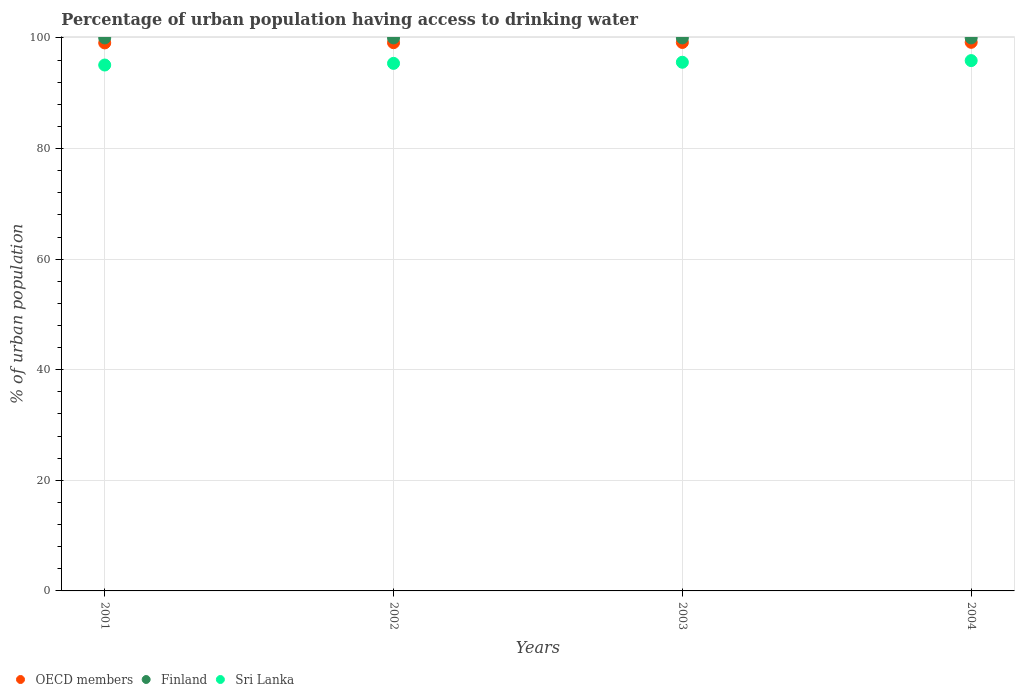How many different coloured dotlines are there?
Offer a very short reply. 3. Is the number of dotlines equal to the number of legend labels?
Your answer should be very brief. Yes. What is the percentage of urban population having access to drinking water in Sri Lanka in 2002?
Offer a very short reply. 95.4. Across all years, what is the maximum percentage of urban population having access to drinking water in OECD members?
Ensure brevity in your answer.  99.21. Across all years, what is the minimum percentage of urban population having access to drinking water in Finland?
Keep it short and to the point. 100. In which year was the percentage of urban population having access to drinking water in OECD members maximum?
Your answer should be compact. 2004. In which year was the percentage of urban population having access to drinking water in Finland minimum?
Your response must be concise. 2001. What is the total percentage of urban population having access to drinking water in Sri Lanka in the graph?
Provide a succinct answer. 382. What is the difference between the percentage of urban population having access to drinking water in Sri Lanka in 2002 and that in 2003?
Keep it short and to the point. -0.2. What is the difference between the percentage of urban population having access to drinking water in OECD members in 2004 and the percentage of urban population having access to drinking water in Finland in 2003?
Your answer should be compact. -0.79. In the year 2001, what is the difference between the percentage of urban population having access to drinking water in Sri Lanka and percentage of urban population having access to drinking water in Finland?
Ensure brevity in your answer.  -4.9. In how many years, is the percentage of urban population having access to drinking water in Finland greater than 12 %?
Your response must be concise. 4. Is the percentage of urban population having access to drinking water in OECD members in 2002 less than that in 2003?
Your answer should be very brief. Yes. What is the difference between the highest and the second highest percentage of urban population having access to drinking water in OECD members?
Offer a terse response. 0.03. What is the difference between the highest and the lowest percentage of urban population having access to drinking water in Sri Lanka?
Your answer should be compact. 0.8. Is the sum of the percentage of urban population having access to drinking water in Sri Lanka in 2002 and 2003 greater than the maximum percentage of urban population having access to drinking water in OECD members across all years?
Keep it short and to the point. Yes. Is it the case that in every year, the sum of the percentage of urban population having access to drinking water in OECD members and percentage of urban population having access to drinking water in Finland  is greater than the percentage of urban population having access to drinking water in Sri Lanka?
Ensure brevity in your answer.  Yes. Is the percentage of urban population having access to drinking water in OECD members strictly less than the percentage of urban population having access to drinking water in Finland over the years?
Provide a succinct answer. Yes. What is the difference between two consecutive major ticks on the Y-axis?
Offer a terse response. 20. Does the graph contain grids?
Ensure brevity in your answer.  Yes. How many legend labels are there?
Your response must be concise. 3. What is the title of the graph?
Offer a very short reply. Percentage of urban population having access to drinking water. What is the label or title of the X-axis?
Give a very brief answer. Years. What is the label or title of the Y-axis?
Give a very brief answer. % of urban population. What is the % of urban population in OECD members in 2001?
Your response must be concise. 99.1. What is the % of urban population in Finland in 2001?
Offer a very short reply. 100. What is the % of urban population of Sri Lanka in 2001?
Provide a short and direct response. 95.1. What is the % of urban population of OECD members in 2002?
Offer a very short reply. 99.14. What is the % of urban population in Finland in 2002?
Give a very brief answer. 100. What is the % of urban population of Sri Lanka in 2002?
Provide a short and direct response. 95.4. What is the % of urban population in OECD members in 2003?
Your answer should be very brief. 99.18. What is the % of urban population of Sri Lanka in 2003?
Keep it short and to the point. 95.6. What is the % of urban population of OECD members in 2004?
Make the answer very short. 99.21. What is the % of urban population in Finland in 2004?
Give a very brief answer. 100. What is the % of urban population of Sri Lanka in 2004?
Keep it short and to the point. 95.9. Across all years, what is the maximum % of urban population in OECD members?
Make the answer very short. 99.21. Across all years, what is the maximum % of urban population in Sri Lanka?
Provide a succinct answer. 95.9. Across all years, what is the minimum % of urban population in OECD members?
Provide a short and direct response. 99.1. Across all years, what is the minimum % of urban population of Sri Lanka?
Your answer should be compact. 95.1. What is the total % of urban population of OECD members in the graph?
Give a very brief answer. 396.63. What is the total % of urban population in Finland in the graph?
Provide a short and direct response. 400. What is the total % of urban population of Sri Lanka in the graph?
Give a very brief answer. 382. What is the difference between the % of urban population in OECD members in 2001 and that in 2002?
Ensure brevity in your answer.  -0.04. What is the difference between the % of urban population in Finland in 2001 and that in 2002?
Keep it short and to the point. 0. What is the difference between the % of urban population in OECD members in 2001 and that in 2003?
Offer a very short reply. -0.08. What is the difference between the % of urban population in Finland in 2001 and that in 2003?
Provide a short and direct response. 0. What is the difference between the % of urban population of Sri Lanka in 2001 and that in 2003?
Your answer should be compact. -0.5. What is the difference between the % of urban population of OECD members in 2001 and that in 2004?
Ensure brevity in your answer.  -0.11. What is the difference between the % of urban population in Finland in 2001 and that in 2004?
Your response must be concise. 0. What is the difference between the % of urban population in Sri Lanka in 2001 and that in 2004?
Make the answer very short. -0.8. What is the difference between the % of urban population in OECD members in 2002 and that in 2003?
Keep it short and to the point. -0.04. What is the difference between the % of urban population of Finland in 2002 and that in 2003?
Your response must be concise. 0. What is the difference between the % of urban population in OECD members in 2002 and that in 2004?
Keep it short and to the point. -0.06. What is the difference between the % of urban population in OECD members in 2003 and that in 2004?
Keep it short and to the point. -0.03. What is the difference between the % of urban population of OECD members in 2001 and the % of urban population of Finland in 2002?
Offer a very short reply. -0.9. What is the difference between the % of urban population in OECD members in 2001 and the % of urban population in Sri Lanka in 2002?
Keep it short and to the point. 3.7. What is the difference between the % of urban population of OECD members in 2001 and the % of urban population of Finland in 2003?
Provide a short and direct response. -0.9. What is the difference between the % of urban population in OECD members in 2001 and the % of urban population in Sri Lanka in 2003?
Your answer should be compact. 3.5. What is the difference between the % of urban population in Finland in 2001 and the % of urban population in Sri Lanka in 2003?
Make the answer very short. 4.4. What is the difference between the % of urban population in OECD members in 2001 and the % of urban population in Finland in 2004?
Your answer should be compact. -0.9. What is the difference between the % of urban population in OECD members in 2001 and the % of urban population in Sri Lanka in 2004?
Offer a very short reply. 3.2. What is the difference between the % of urban population of Finland in 2001 and the % of urban population of Sri Lanka in 2004?
Give a very brief answer. 4.1. What is the difference between the % of urban population of OECD members in 2002 and the % of urban population of Finland in 2003?
Ensure brevity in your answer.  -0.86. What is the difference between the % of urban population of OECD members in 2002 and the % of urban population of Sri Lanka in 2003?
Make the answer very short. 3.54. What is the difference between the % of urban population in OECD members in 2002 and the % of urban population in Finland in 2004?
Offer a very short reply. -0.86. What is the difference between the % of urban population of OECD members in 2002 and the % of urban population of Sri Lanka in 2004?
Ensure brevity in your answer.  3.24. What is the difference between the % of urban population of OECD members in 2003 and the % of urban population of Finland in 2004?
Provide a succinct answer. -0.82. What is the difference between the % of urban population in OECD members in 2003 and the % of urban population in Sri Lanka in 2004?
Your answer should be compact. 3.28. What is the average % of urban population in OECD members per year?
Your response must be concise. 99.16. What is the average % of urban population of Finland per year?
Provide a short and direct response. 100. What is the average % of urban population of Sri Lanka per year?
Keep it short and to the point. 95.5. In the year 2001, what is the difference between the % of urban population of OECD members and % of urban population of Finland?
Offer a very short reply. -0.9. In the year 2001, what is the difference between the % of urban population in OECD members and % of urban population in Sri Lanka?
Offer a terse response. 4. In the year 2002, what is the difference between the % of urban population of OECD members and % of urban population of Finland?
Offer a terse response. -0.86. In the year 2002, what is the difference between the % of urban population in OECD members and % of urban population in Sri Lanka?
Keep it short and to the point. 3.74. In the year 2003, what is the difference between the % of urban population of OECD members and % of urban population of Finland?
Ensure brevity in your answer.  -0.82. In the year 2003, what is the difference between the % of urban population of OECD members and % of urban population of Sri Lanka?
Make the answer very short. 3.58. In the year 2003, what is the difference between the % of urban population in Finland and % of urban population in Sri Lanka?
Offer a terse response. 4.4. In the year 2004, what is the difference between the % of urban population in OECD members and % of urban population in Finland?
Keep it short and to the point. -0.79. In the year 2004, what is the difference between the % of urban population in OECD members and % of urban population in Sri Lanka?
Offer a terse response. 3.31. In the year 2004, what is the difference between the % of urban population of Finland and % of urban population of Sri Lanka?
Your answer should be compact. 4.1. What is the ratio of the % of urban population in Finland in 2001 to that in 2002?
Make the answer very short. 1. What is the ratio of the % of urban population in OECD members in 2001 to that in 2003?
Your answer should be compact. 1. What is the ratio of the % of urban population of OECD members in 2002 to that in 2003?
Offer a very short reply. 1. What is the ratio of the % of urban population in Finland in 2002 to that in 2003?
Offer a very short reply. 1. What is the ratio of the % of urban population of OECD members in 2002 to that in 2004?
Give a very brief answer. 1. What is the ratio of the % of urban population of Finland in 2002 to that in 2004?
Offer a very short reply. 1. What is the ratio of the % of urban population of Finland in 2003 to that in 2004?
Give a very brief answer. 1. What is the difference between the highest and the second highest % of urban population in OECD members?
Offer a very short reply. 0.03. What is the difference between the highest and the lowest % of urban population of OECD members?
Your answer should be compact. 0.11. What is the difference between the highest and the lowest % of urban population in Sri Lanka?
Your answer should be compact. 0.8. 